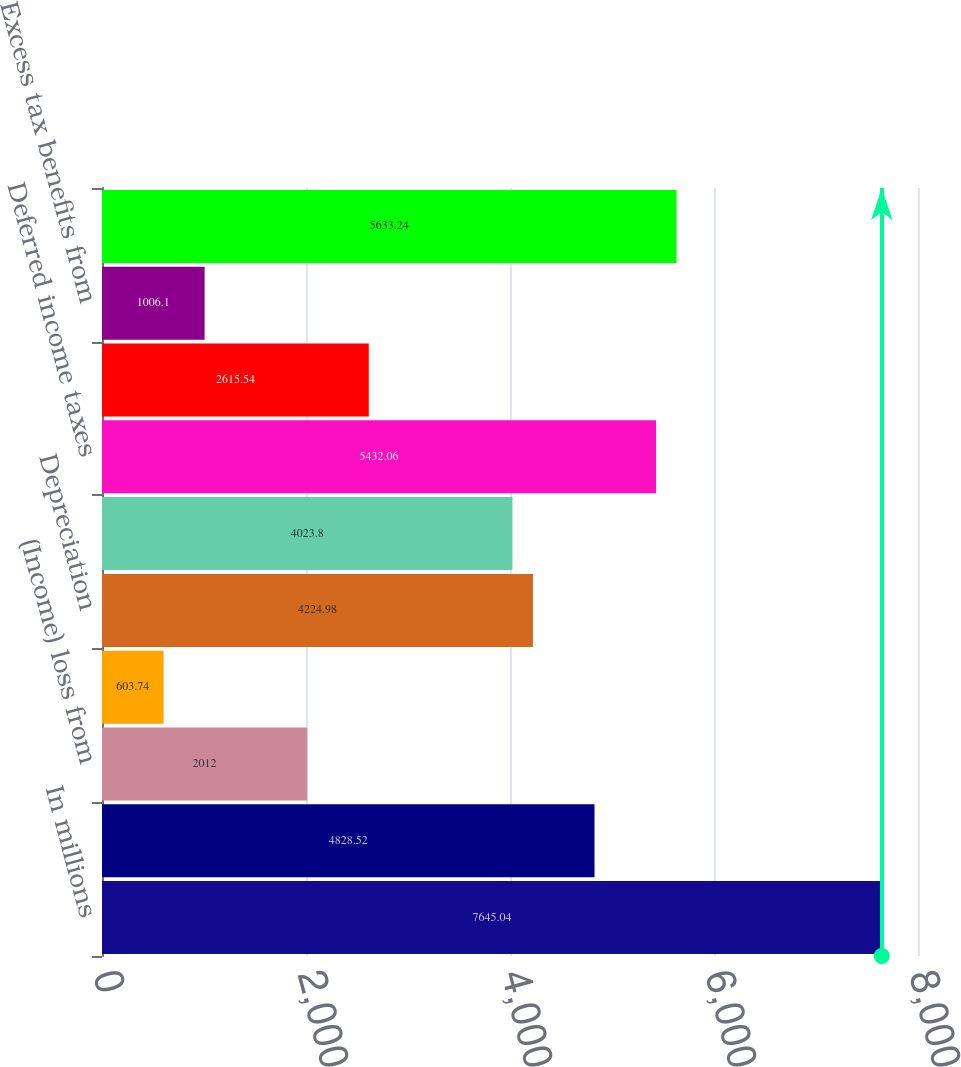Convert chart. <chart><loc_0><loc_0><loc_500><loc_500><bar_chart><fcel>In millions<fcel>Net income (loss) before<fcel>(Income) loss from<fcel>Equity income of<fcel>Depreciation<fcel>Amortization<fcel>Deferred income taxes<fcel>Share-based compensation<fcel>Excess tax benefits from<fcel>Pension and other<nl><fcel>7645.04<fcel>4828.52<fcel>2012<fcel>603.74<fcel>4224.98<fcel>4023.8<fcel>5432.06<fcel>2615.54<fcel>1006.1<fcel>5633.24<nl></chart> 